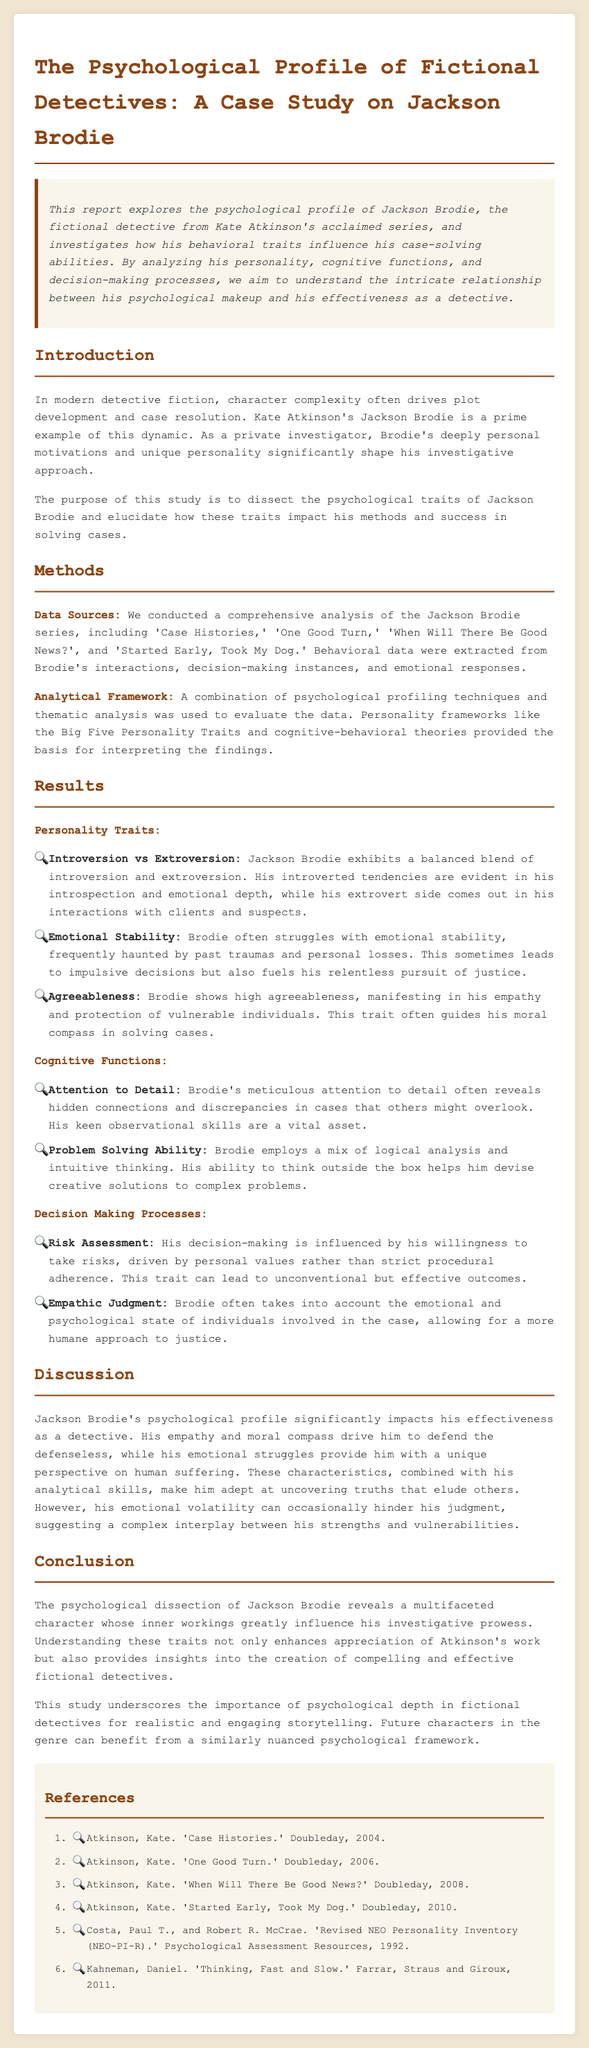what is the title of the report? The title of the report is found at the beginning of the document and is "The Psychological Profile of Fictional Detectives: A Case Study on Jackson Brodie."
Answer: The Psychological Profile of Fictional Detectives: A Case Study on Jackson Brodie who is the author of the series that Jackson Brodie appears in? The author of the series is mentioned in the introduction section of the report as "Kate Atkinson."
Answer: Kate Atkinson how many books in the Jackson Brodie series were analyzed? The document states four specific titles were analyzed for the study, hence the number is four.
Answer: four what personality trait does Jackson Brodie exhibit that influences his case-solving abilities? The report highlights Brodie’s empathy as a significant personality trait influencing his ability to solve cases.
Answer: empathy which cognitive function of Jackson Brodie is highlighted in the results? The results mention "Attention to Detail" as a cognitive function that is particularly notable for Brodie.
Answer: Attention to Detail what emotional challenge does Jackson Brodie struggle with? The document reports that Brodie frequently struggles with "emotional stability."
Answer: emotional stability what does the analytical framework include for interpreting the findings? The framework includes personality frameworks and theories, specifically mentioning the "Big Five Personality Traits."
Answer: Big Five Personality Traits what is the primary focus of the conclusion of the report? The conclusion emphasizes the importance of psychological depth in fictional detectives and its influence on storytelling.
Answer: psychological depth in fictional detectives 